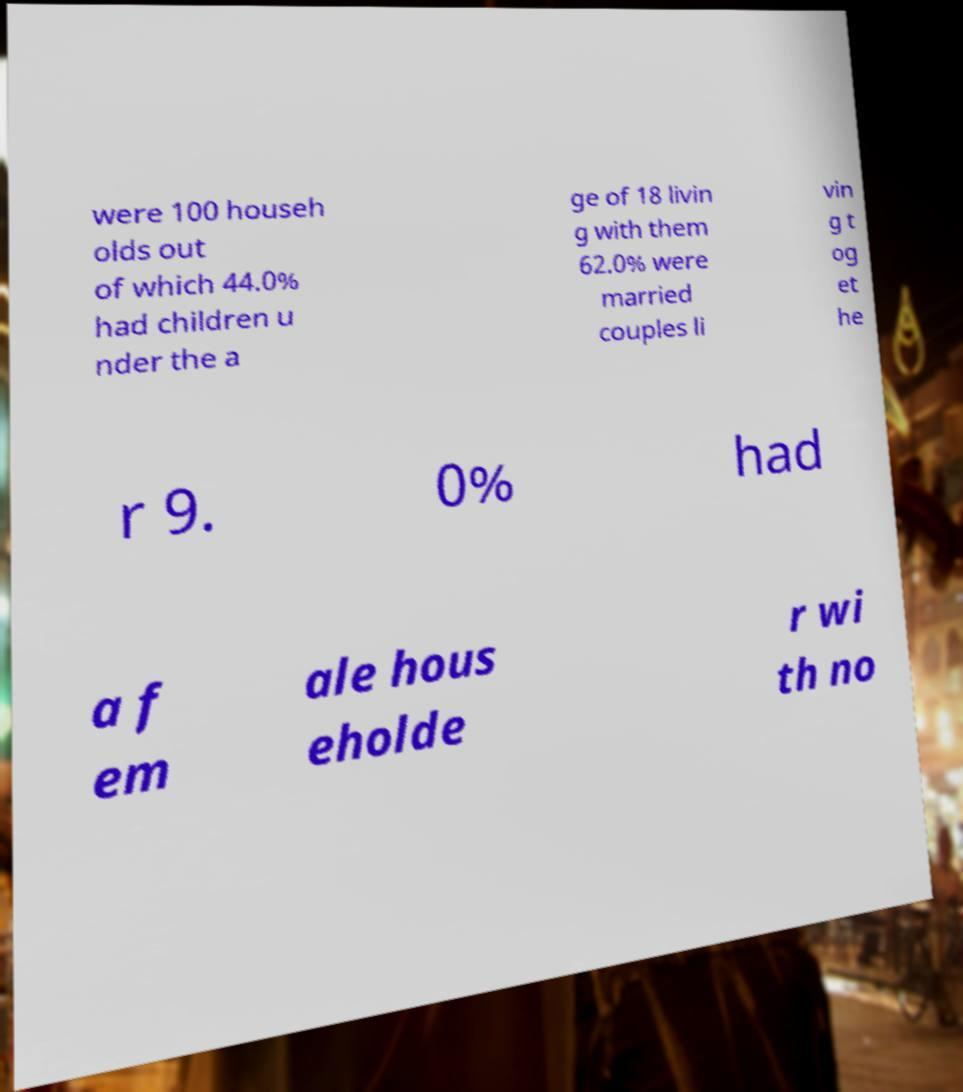Can you accurately transcribe the text from the provided image for me? were 100 househ olds out of which 44.0% had children u nder the a ge of 18 livin g with them 62.0% were married couples li vin g t og et he r 9. 0% had a f em ale hous eholde r wi th no 